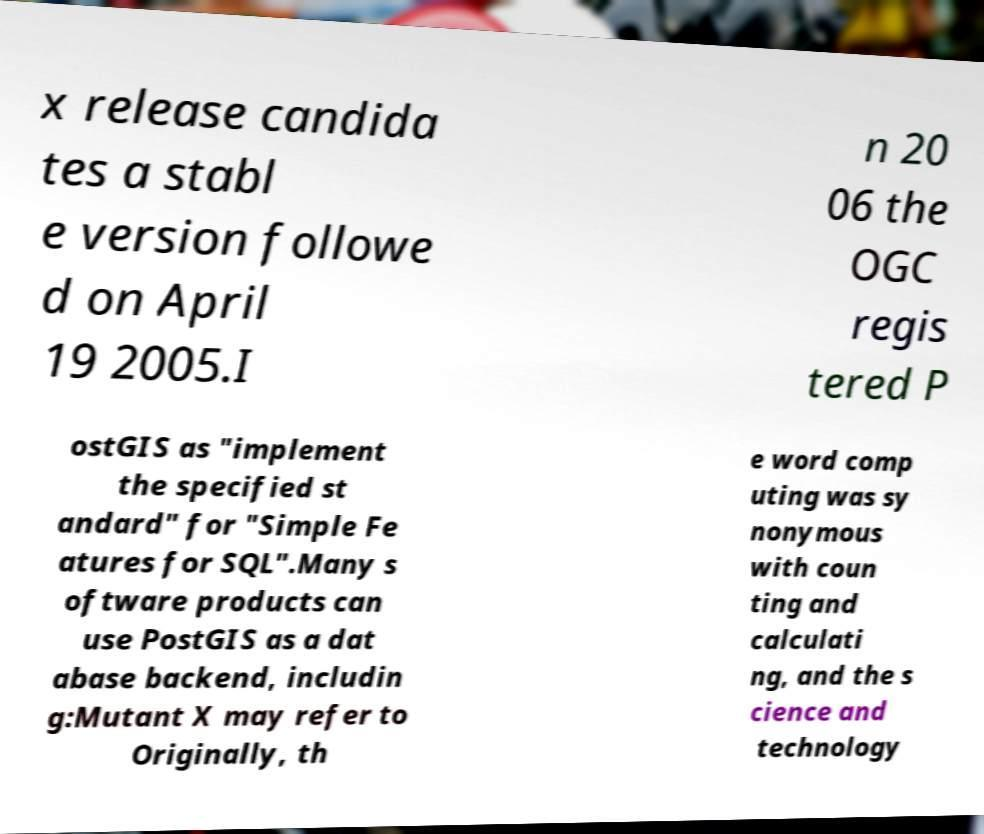Please read and relay the text visible in this image. What does it say? x release candida tes a stabl e version followe d on April 19 2005.I n 20 06 the OGC regis tered P ostGIS as "implement the specified st andard" for "Simple Fe atures for SQL".Many s oftware products can use PostGIS as a dat abase backend, includin g:Mutant X may refer to Originally, th e word comp uting was sy nonymous with coun ting and calculati ng, and the s cience and technology 